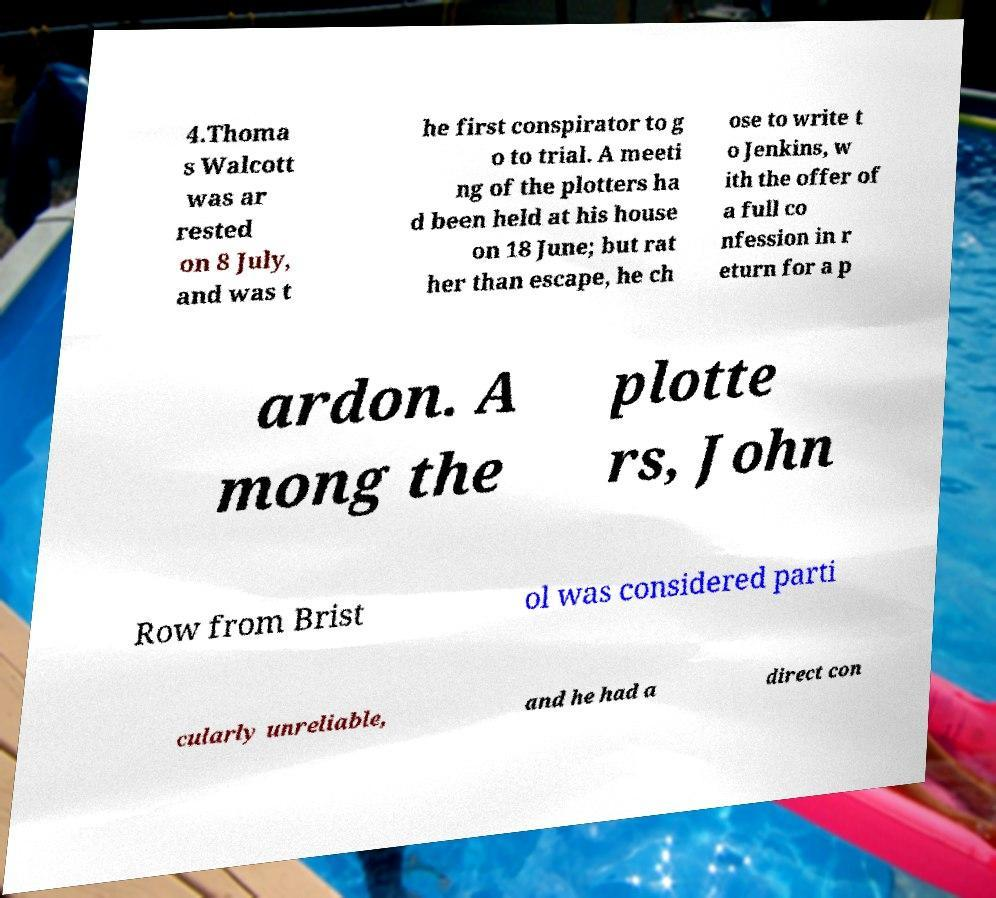For documentation purposes, I need the text within this image transcribed. Could you provide that? 4.Thoma s Walcott was ar rested on 8 July, and was t he first conspirator to g o to trial. A meeti ng of the plotters ha d been held at his house on 18 June; but rat her than escape, he ch ose to write t o Jenkins, w ith the offer of a full co nfession in r eturn for a p ardon. A mong the plotte rs, John Row from Brist ol was considered parti cularly unreliable, and he had a direct con 